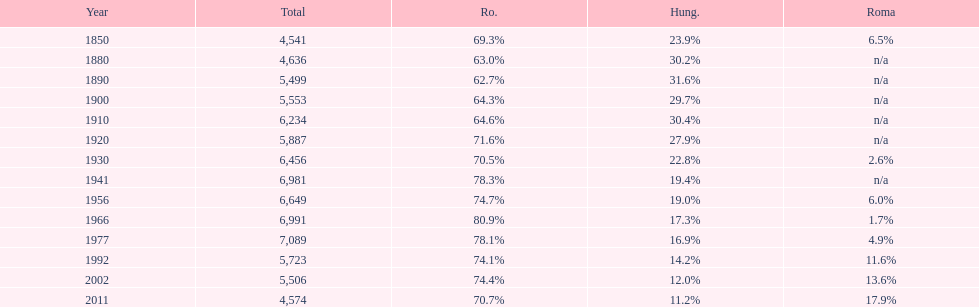What is the number of times the total population was 6,000 or more? 6. 